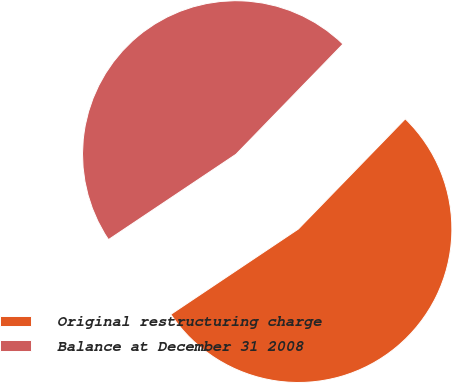<chart> <loc_0><loc_0><loc_500><loc_500><pie_chart><fcel>Original restructuring charge<fcel>Balance at December 31 2008<nl><fcel>53.35%<fcel>46.65%<nl></chart> 